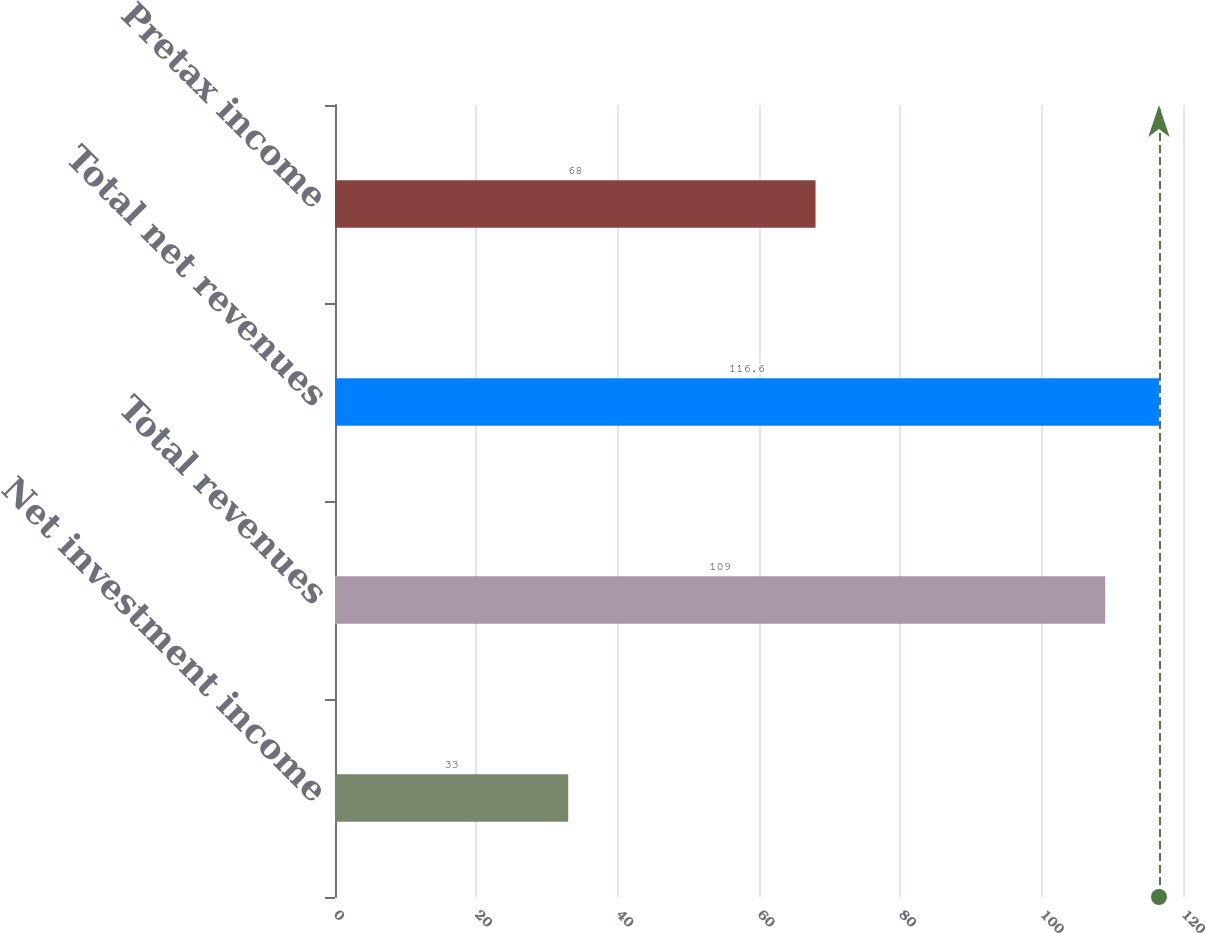Convert chart to OTSL. <chart><loc_0><loc_0><loc_500><loc_500><bar_chart><fcel>Net investment income<fcel>Total revenues<fcel>Total net revenues<fcel>Pretax income<nl><fcel>33<fcel>109<fcel>116.6<fcel>68<nl></chart> 